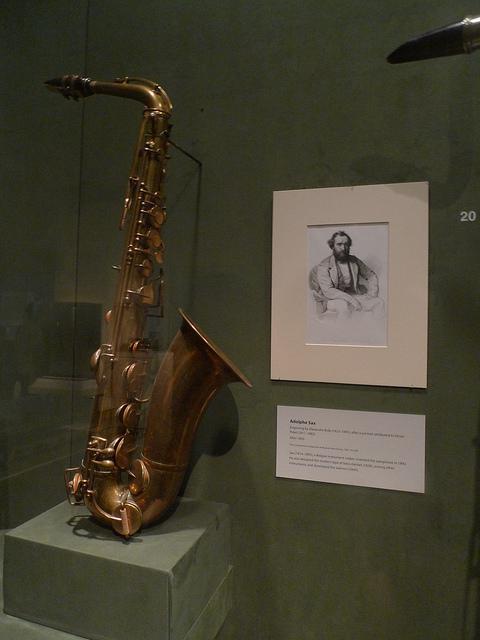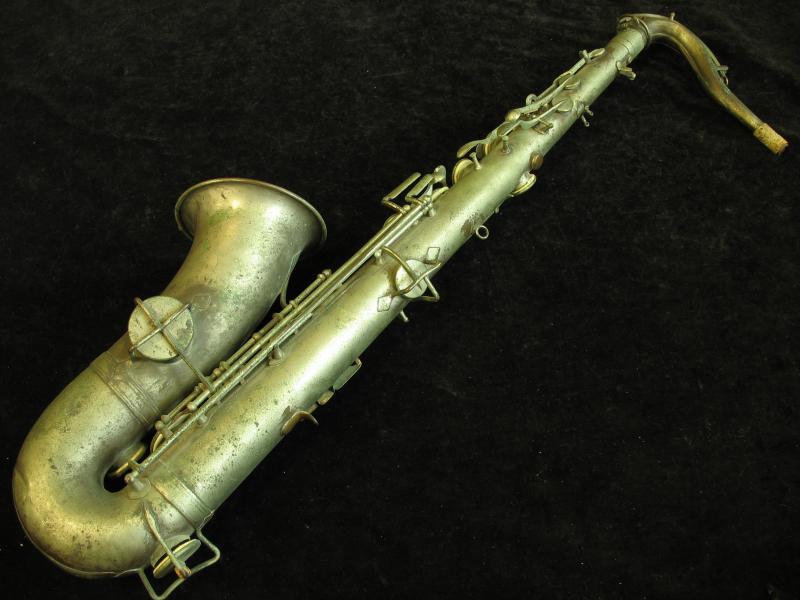The first image is the image on the left, the second image is the image on the right. For the images shown, is this caption "An image shows a brass colored instrument with an imperfect finish on a black background." true? Answer yes or no. Yes. The first image is the image on the left, the second image is the image on the right. Examine the images to the left and right. Is the description "One image shows a saxophone on a plain black background." accurate? Answer yes or no. Yes. 